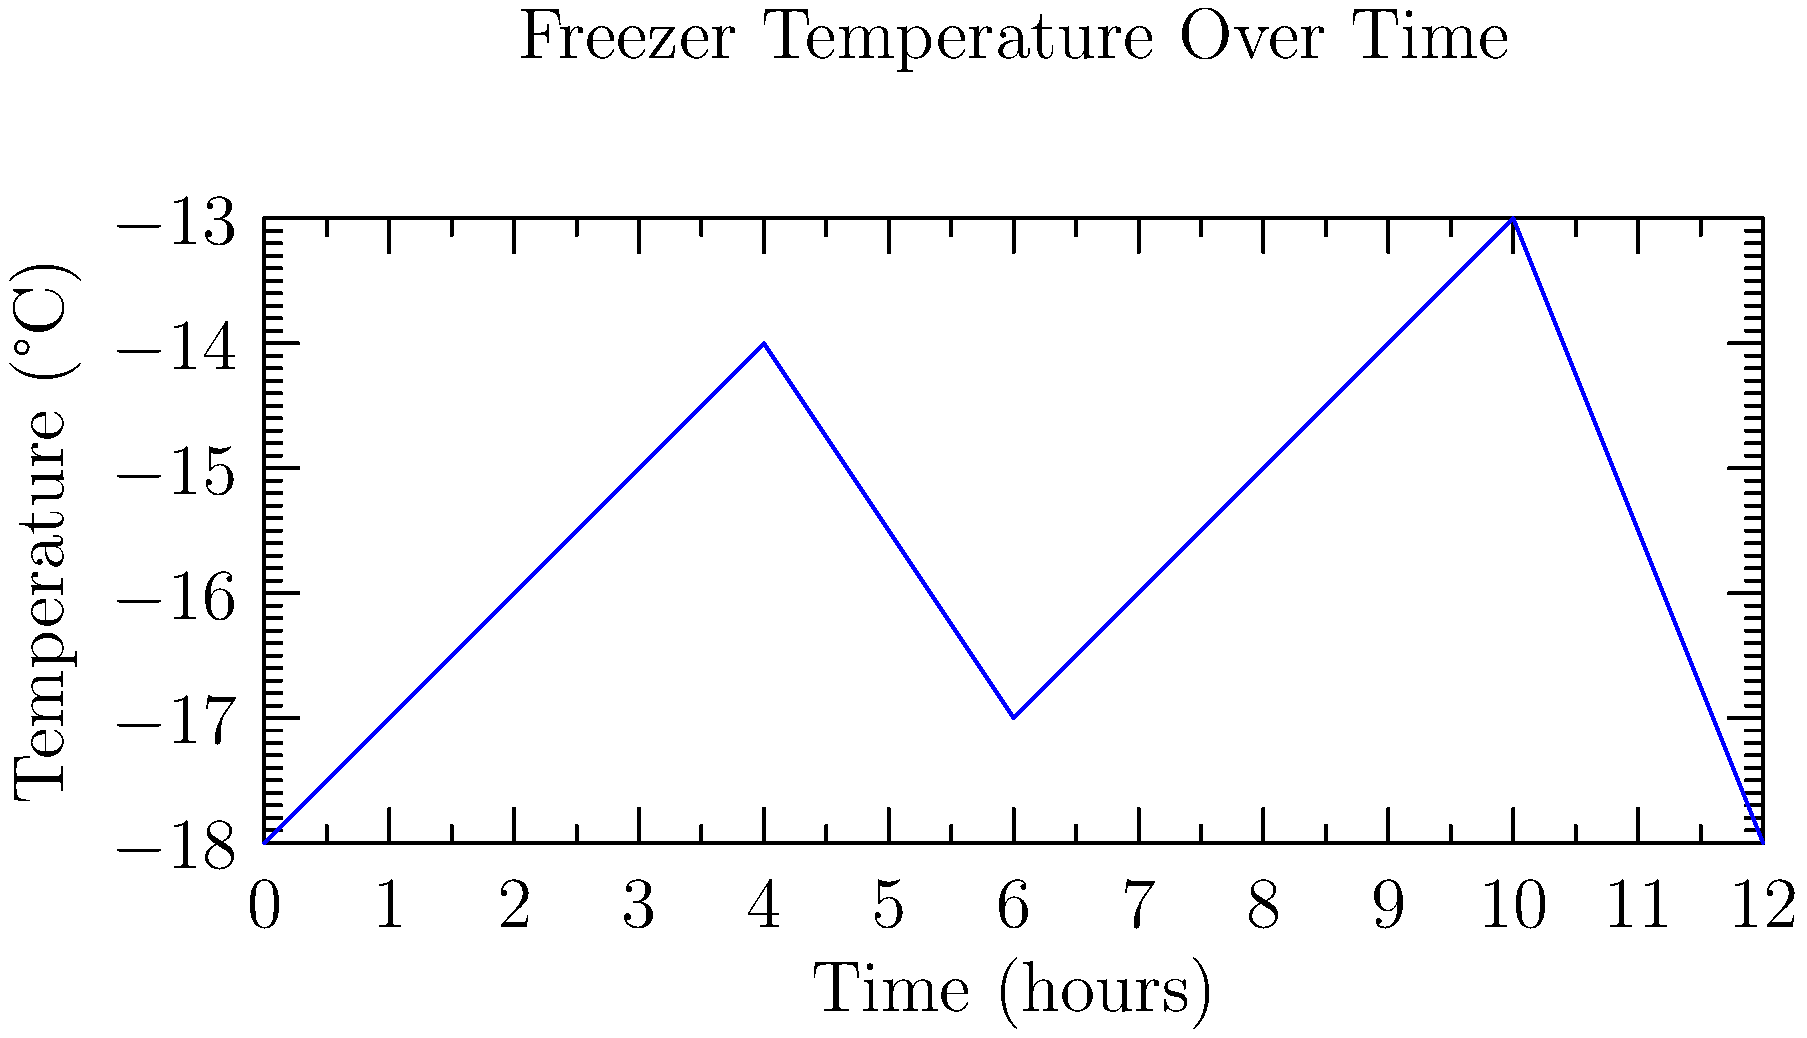As an ice cream van owner, you're monitoring the temperature inside your freezer. The graph shows temperature variations over a 12-hour period. What is the total temperature range (difference between highest and lowest temperatures) observed during this time? To find the total temperature range, we need to follow these steps:

1. Identify the highest temperature:
   The highest point on the graph is at -13°C.

2. Identify the lowest temperature:
   The lowest points on the graph are at -18°C (occurring at both 0 and 12 hours).

3. Calculate the difference:
   Temperature range = Highest temperature - Lowest temperature
   $$ \text{Temperature range} = -13°C - (-18°C) = 5°C $$

The negative signs are important here. Remember that -13 is higher (warmer) than -18 on the temperature scale.
Answer: 5°C 